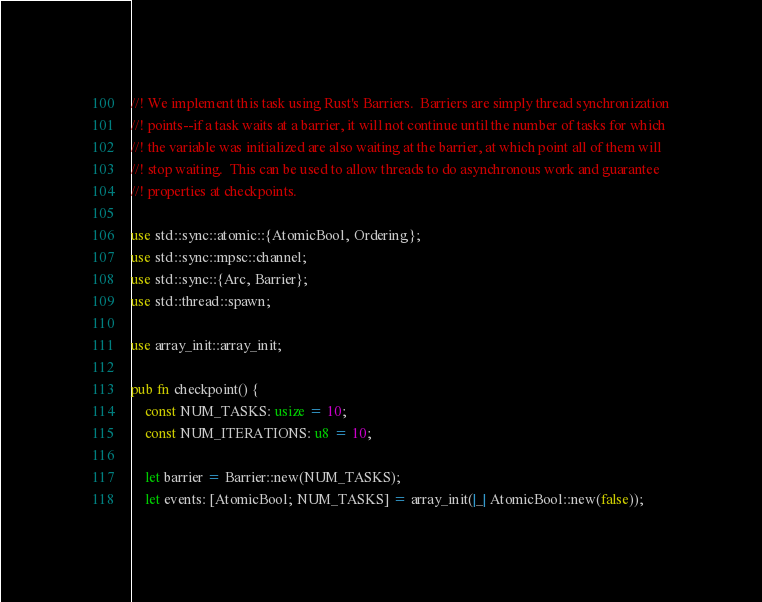<code> <loc_0><loc_0><loc_500><loc_500><_Rust_>//! We implement this task using Rust's Barriers.  Barriers are simply thread synchronization
//! points--if a task waits at a barrier, it will not continue until the number of tasks for which
//! the variable was initialized are also waiting at the barrier, at which point all of them will
//! stop waiting.  This can be used to allow threads to do asynchronous work and guarantee
//! properties at checkpoints.

use std::sync::atomic::{AtomicBool, Ordering};
use std::sync::mpsc::channel;
use std::sync::{Arc, Barrier};
use std::thread::spawn;

use array_init::array_init;

pub fn checkpoint() {
    const NUM_TASKS: usize = 10;
    const NUM_ITERATIONS: u8 = 10;

    let barrier = Barrier::new(NUM_TASKS);
    let events: [AtomicBool; NUM_TASKS] = array_init(|_| AtomicBool::new(false));
</code> 